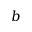<formula> <loc_0><loc_0><loc_500><loc_500>b</formula> 